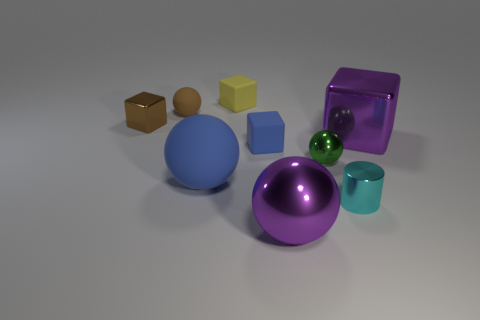Do the large metal thing that is on the left side of the tiny cyan cylinder and the matte thing that is left of the big blue matte sphere have the same shape? Yes, both the large metallic object to the left of the small cyan cylinder and the matte object to the left of the large blue matte sphere are cubes, exhibiting the same six-faced, square-edged shape. 